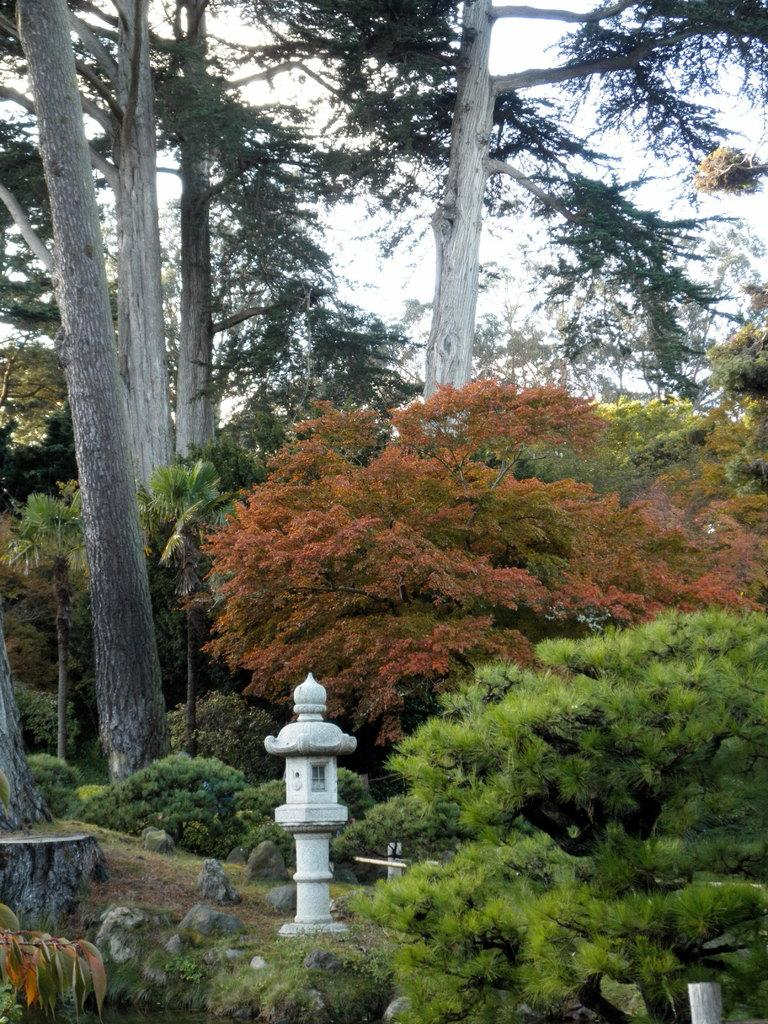What type of vegetation can be seen in the image? There are trees and plants in the image. What is located in the center of the image? There is a pole in the center of the image. What is present at the bottom of the image? There are rocks at the bottom of the image. What can be seen in the background of the image? The sky is visible in the background of the image. What type of news can be seen on the jelly in the image? There is no news or jelly present in the image. How can one rest in the image? The image does not depict a place or situation where one can rest. 